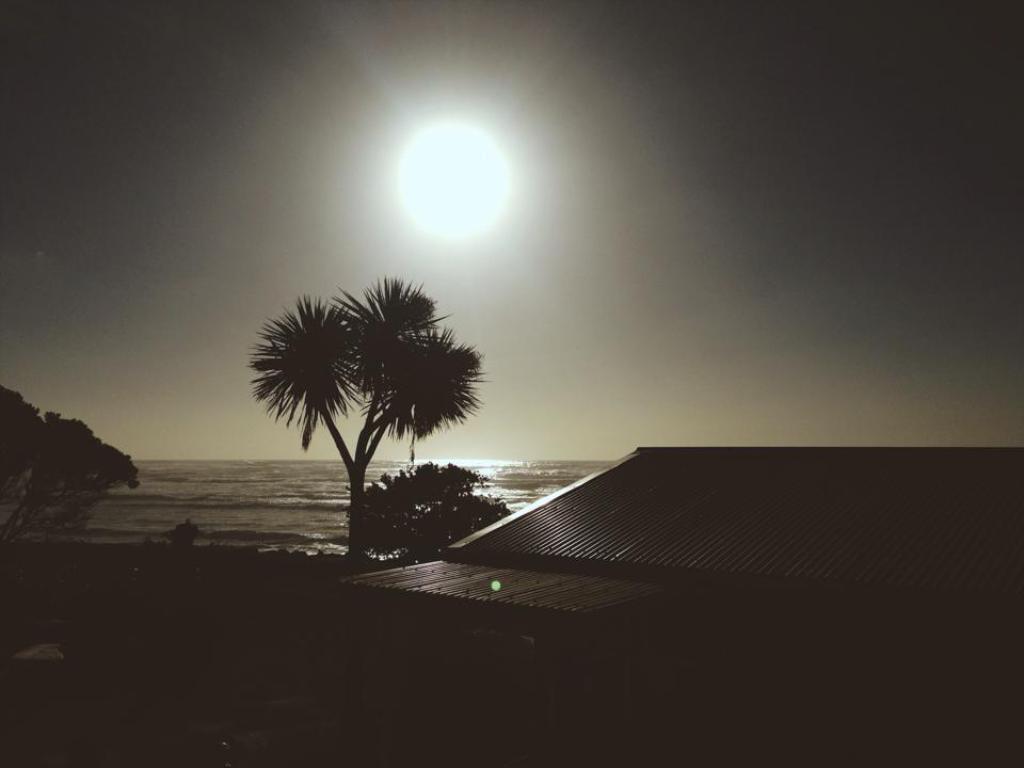Please provide a concise description of this image. On the right side there is a building. There are trees. In the back there is water and sky with sun. 